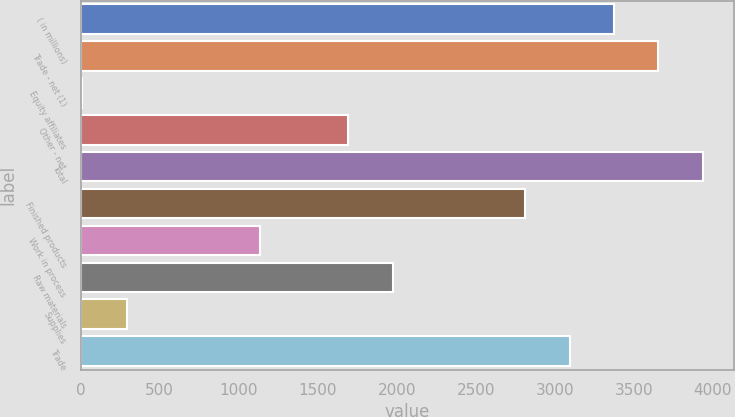Convert chart. <chart><loc_0><loc_0><loc_500><loc_500><bar_chart><fcel>( in millions)<fcel>Trade - net (1)<fcel>Equity affiliates<fcel>Other - net<fcel>Total<fcel>Finished products<fcel>Work in process<fcel>Raw materials<fcel>Supplies<fcel>Trade<nl><fcel>3376<fcel>3656.5<fcel>10<fcel>1693<fcel>3937<fcel>2815<fcel>1132<fcel>1973.5<fcel>290.5<fcel>3095.5<nl></chart> 